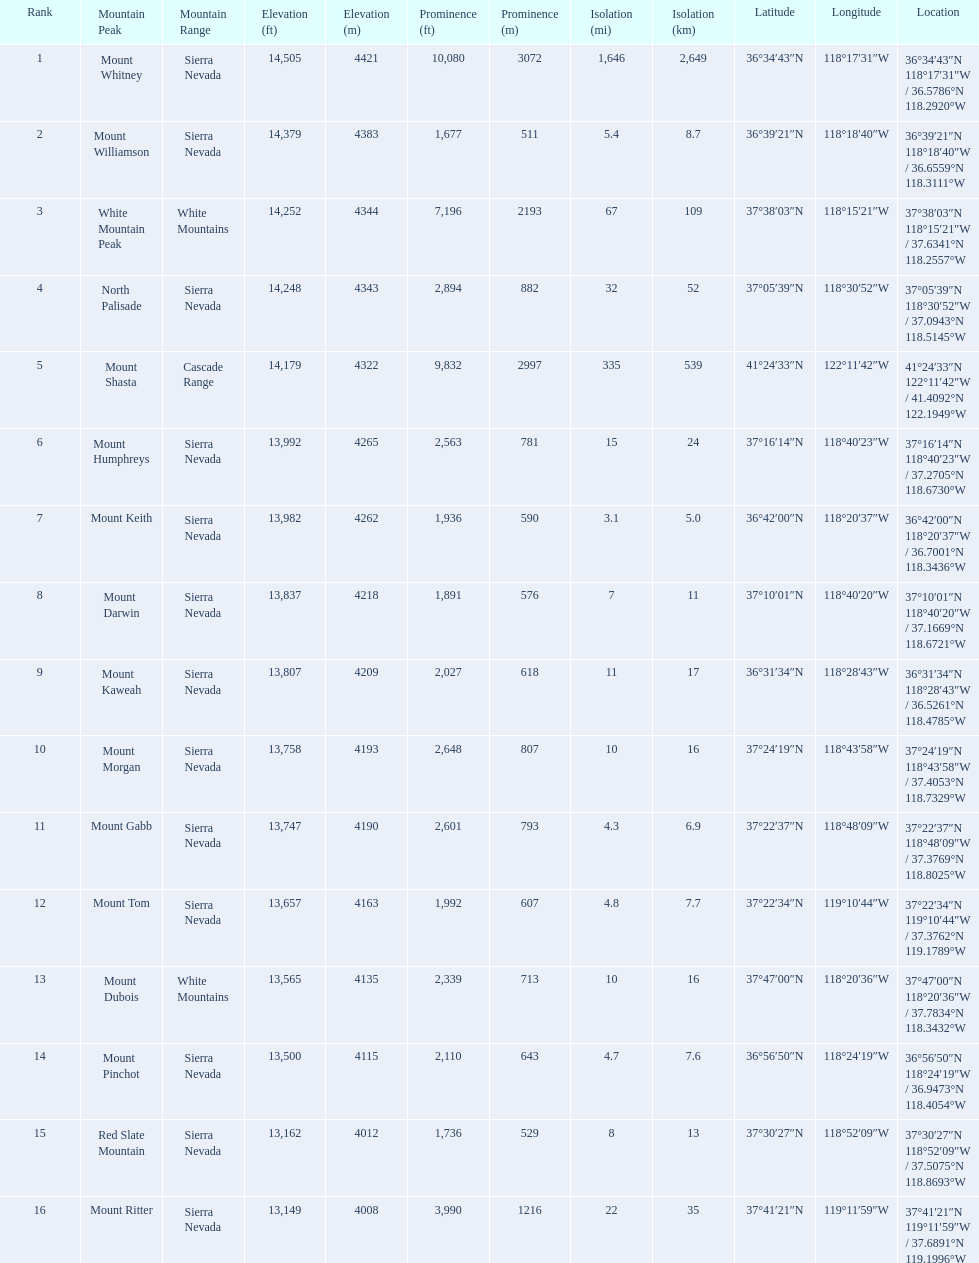What mountain peak is listed for the sierra nevada mountain range? Mount Whitney. What mountain peak has an elevation of 14,379ft? Mount Williamson. Which mountain is listed for the cascade range? Mount Shasta. 